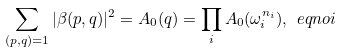Convert formula to latex. <formula><loc_0><loc_0><loc_500><loc_500>\sum _ { ( p , q ) = 1 } | \beta ( p , q ) | ^ { 2 } = A _ { 0 } ( q ) = \prod _ { i } A _ { 0 } ( \omega _ { i } ^ { n _ { i } } ) , \ e q n o i</formula> 